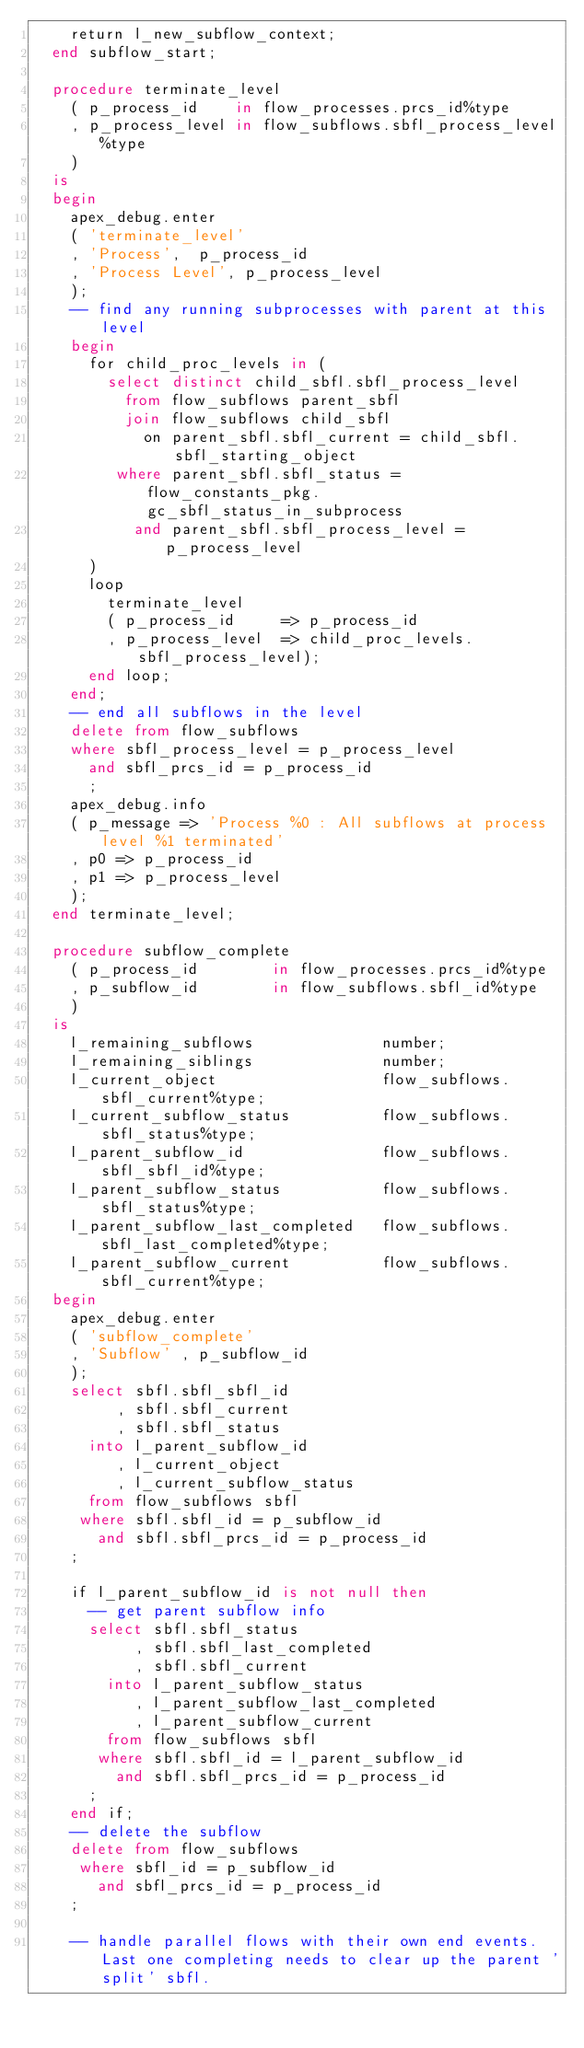Convert code to text. <code><loc_0><loc_0><loc_500><loc_500><_SQL_>    return l_new_subflow_context;
  end subflow_start;

  procedure terminate_level
    ( p_process_id    in flow_processes.prcs_id%type
    , p_process_level in flow_subflows.sbfl_process_level%type
    )
  is
  begin
    apex_debug.enter
    ( 'terminate_level'
    , 'Process',  p_process_id
    , 'Process Level', p_process_level
    );
    -- find any running subprocesses with parent at this level
    begin
      for child_proc_levels in (
        select distinct child_sbfl.sbfl_process_level
          from flow_subflows parent_sbfl
          join flow_subflows child_sbfl
            on parent_sbfl.sbfl_current = child_sbfl.sbfl_starting_object
         where parent_sbfl.sbfl_status =  flow_constants_pkg.gc_sbfl_status_in_subprocess
           and parent_sbfl.sbfl_process_level = p_process_level
      )
      loop
        terminate_level
        ( p_process_id     => p_process_id
        , p_process_level  => child_proc_levels.sbfl_process_level);
      end loop;
    end;
    -- end all subflows in the level
    delete from flow_subflows
    where sbfl_process_level = p_process_level 
      and sbfl_prcs_id = p_process_id
      ;
    apex_debug.info 
    ( p_message => 'Process %0 : All subflows at process level %1 terminated'
    , p0 => p_process_id
    , p1 => p_process_level
    );
  end terminate_level;

  procedure subflow_complete
    ( p_process_id        in flow_processes.prcs_id%type
    , p_subflow_id        in flow_subflows.sbfl_id%type
    )
  is
    l_remaining_subflows              number;
    l_remaining_siblings              number;
    l_current_object                  flow_subflows.sbfl_current%type;
    l_current_subflow_status          flow_subflows.sbfl_status%type;
    l_parent_subflow_id               flow_subflows.sbfl_sbfl_id%type;
    l_parent_subflow_status           flow_subflows.sbfl_status%type;
    l_parent_subflow_last_completed   flow_subflows.sbfl_last_completed%type;
    l_parent_subflow_current          flow_subflows.sbfl_current%type;
  begin
    apex_debug.enter
    ( 'subflow_complete'
    , 'Subflow' , p_subflow_id 
    );
    select sbfl.sbfl_sbfl_id
         , sbfl.sbfl_current
         , sbfl.sbfl_status
      into l_parent_subflow_id
         , l_current_object
         , l_current_subflow_status
      from flow_subflows sbfl
     where sbfl.sbfl_id = p_subflow_id
       and sbfl.sbfl_prcs_id = p_process_id
    ; 
    
    if l_parent_subflow_id is not null then   
      -- get parent subflow info
      select sbfl.sbfl_status
           , sbfl.sbfl_last_completed
           , sbfl.sbfl_current
        into l_parent_subflow_status
           , l_parent_subflow_last_completed
           , l_parent_subflow_current
        from flow_subflows sbfl
       where sbfl.sbfl_id = l_parent_subflow_id
         and sbfl.sbfl_prcs_id = p_process_id
      ;
    end if;
    -- delete the subflow
    delete from flow_subflows
     where sbfl_id = p_subflow_id
       and sbfl_prcs_id = p_process_id
    ;

    -- handle parallel flows with their own end events.  Last one completing needs to clear up the parent 'split' sbfl.</code> 